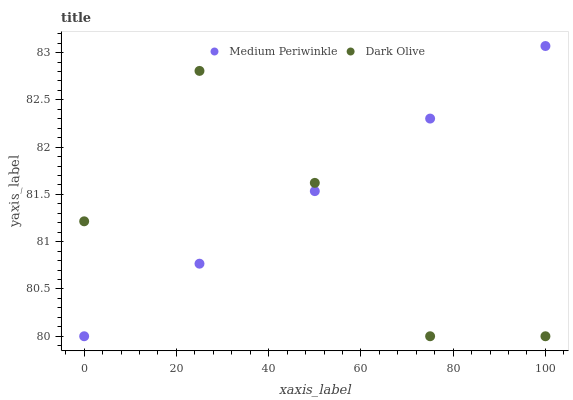Does Dark Olive have the minimum area under the curve?
Answer yes or no. Yes. Does Medium Periwinkle have the maximum area under the curve?
Answer yes or no. Yes. Does Medium Periwinkle have the minimum area under the curve?
Answer yes or no. No. Is Medium Periwinkle the smoothest?
Answer yes or no. Yes. Is Dark Olive the roughest?
Answer yes or no. Yes. Is Medium Periwinkle the roughest?
Answer yes or no. No. Does Dark Olive have the lowest value?
Answer yes or no. Yes. Does Medium Periwinkle have the highest value?
Answer yes or no. Yes. Does Medium Periwinkle intersect Dark Olive?
Answer yes or no. Yes. Is Medium Periwinkle less than Dark Olive?
Answer yes or no. No. Is Medium Periwinkle greater than Dark Olive?
Answer yes or no. No. 